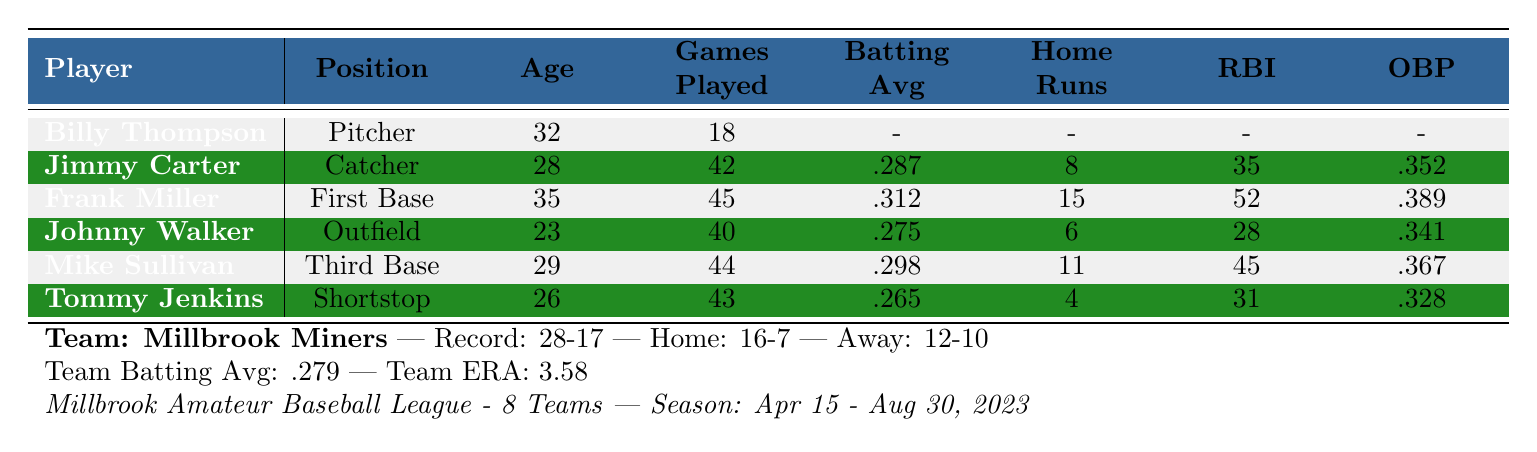What is the batting average of Frank Miller? The table lists Frank Miller's batting average as .312.
Answer: .312 How many home runs did Tommy Jenkins hit this season? The table shows that Tommy Jenkins hit 4 home runs.
Answer: 4 Who has the highest fielding percentage among the players? Frank Miller has the highest fielding percentage at .998 compared to others.
Answer: Frank Miller What is the total number of strikeouts recorded by Billy Thompson? Billy Thompson's strikeouts are given in the table as 87.
Answer: 87 How many games has Johnny Walker played this season? According to the table, Johnny Walker has played 40 games.
Answer: 40 Which player has the most runs batted in (RBI) this season? Frank Miller has the highest number of runs batted in with 52.
Answer: Frank Miller What is the overall win-loss record for the Millbrook Miners? The table presents the Millbrook Miners' record as 28 wins and 17 losses.
Answer: 28-17 What is the difference between runs scored and runs allowed for the Millbrook Miners? The runs scored are 218 and runs allowed are 187; thus, the difference is 218 - 187 = 31.
Answer: 31 Is Jimmy Carter's on-base percentage higher than that of Tommy Jenkins? Jimmy Carter's on-base percentage is .352, while Tommy Jenkins has .328, confirming that Jimmy Carter's is higher.
Answer: Yes If you sum up the games played by all players listed, what do you get? The total games played is 18 + 42 + 45 + 40 + 44 + 43 = 232.
Answer: 232 Which player has the lowest batting average this season? Tommy Jenkins has the lowest batting average at .265 compared to other players.
Answer: Tommy Jenkins How does the Millbrook Miners' team ERA compare to Billy Thompson's earned run average? The team ERA is 3.58 while Billy Thompson's earned run average is 3.21, making the team's ERA higher.
Answer: Higher 